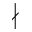<formula> <loc_0><loc_0><loc_500><loc_500>\nmid</formula> 